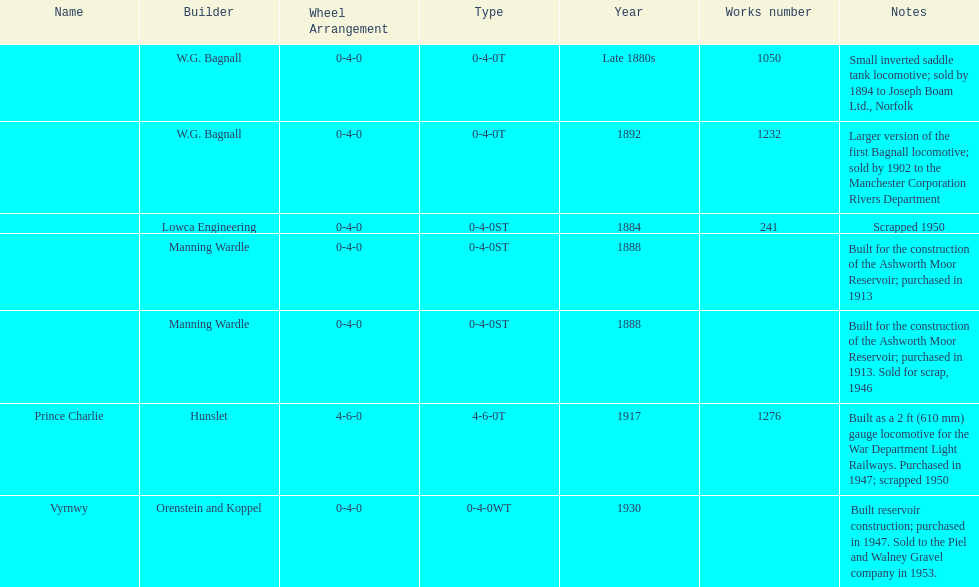Help me parse the entirety of this table. {'header': ['Name', 'Builder', 'Wheel Arrangement', 'Type', 'Year', 'Works number', 'Notes'], 'rows': [['', 'W.G. Bagnall', '0-4-0', '0-4-0T', 'Late 1880s', '1050', 'Small inverted saddle tank locomotive; sold by 1894 to Joseph Boam Ltd., Norfolk'], ['', 'W.G. Bagnall', '0-4-0', '0-4-0T', '1892', '1232', 'Larger version of the first Bagnall locomotive; sold by 1902 to the Manchester Corporation Rivers Department'], ['', 'Lowca Engineering', '0-4-0', '0-4-0ST', '1884', '241', 'Scrapped 1950'], ['', 'Manning Wardle', '0-4-0', '0-4-0ST', '1888', '', 'Built for the construction of the Ashworth Moor Reservoir; purchased in 1913'], ['', 'Manning Wardle', '0-4-0', '0-4-0ST', '1888', '', 'Built for the construction of the Ashworth Moor Reservoir; purchased in 1913. Sold for scrap, 1946'], ['Prince Charlie', 'Hunslet', '4-6-0', '4-6-0T', '1917', '1276', 'Built as a 2\xa0ft (610\xa0mm) gauge locomotive for the War Department Light Railways. Purchased in 1947; scrapped 1950'], ['Vyrnwy', 'Orenstein and Koppel', '0-4-0', '0-4-0WT', '1930', '', 'Built reservoir construction; purchased in 1947. Sold to the Piel and Walney Gravel company in 1953.']]} Who built the larger version of the first bagnall locomotive? W.G. Bagnall. 